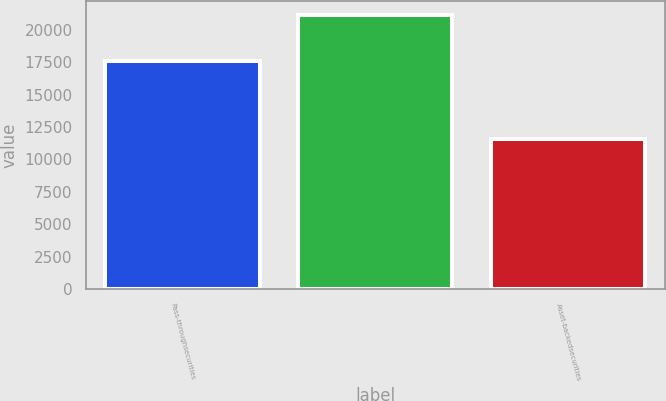Convert chart. <chart><loc_0><loc_0><loc_500><loc_500><bar_chart><fcel>Pass-throughsecurities<fcel>Unnamed: 1<fcel>Asset-backedsecurities<nl><fcel>17567<fcel>21134.3<fcel>11573<nl></chart> 